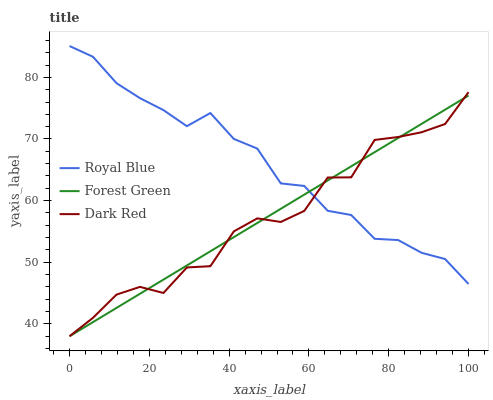Does Dark Red have the minimum area under the curve?
Answer yes or no. Yes. Does Royal Blue have the maximum area under the curve?
Answer yes or no. Yes. Does Forest Green have the minimum area under the curve?
Answer yes or no. No. Does Forest Green have the maximum area under the curve?
Answer yes or no. No. Is Forest Green the smoothest?
Answer yes or no. Yes. Is Dark Red the roughest?
Answer yes or no. Yes. Is Dark Red the smoothest?
Answer yes or no. No. Is Forest Green the roughest?
Answer yes or no. No. Does Forest Green have the lowest value?
Answer yes or no. Yes. Does Royal Blue have the highest value?
Answer yes or no. Yes. Does Dark Red have the highest value?
Answer yes or no. No. Does Royal Blue intersect Dark Red?
Answer yes or no. Yes. Is Royal Blue less than Dark Red?
Answer yes or no. No. Is Royal Blue greater than Dark Red?
Answer yes or no. No. 